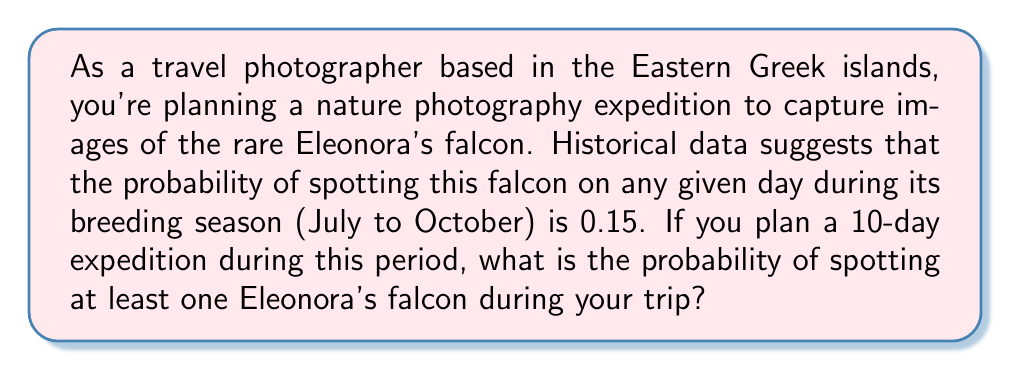Teach me how to tackle this problem. Let's approach this step-by-step:

1) First, we need to define our random variable. Let X be the number of days on which we spot at least one Eleonora's falcon during the 10-day trip.

2) The probability of spotting a falcon on any given day is 0.15, so the probability of not spotting one is 1 - 0.15 = 0.85.

3) We want to find the probability of spotting at least one falcon during the entire trip. This is equivalent to 1 minus the probability of not spotting any falcons on all 10 days.

4) The probability of not spotting any falcons for all 10 days is:

   $$(0.85)^{10}$$

5) Therefore, the probability of spotting at least one falcon is:

   $$P(X \geq 1) = 1 - (0.85)^{10}$$

6) Let's calculate this:

   $$1 - (0.85)^{10} = 1 - 0.1968 = 0.8032$$

7) We can express this as a percentage:

   $$0.8032 \times 100\% = 80.32\%$$

Thus, there is approximately an 80.32% chance of spotting at least one Eleonora's falcon during your 10-day expedition.
Answer: 80.32% 